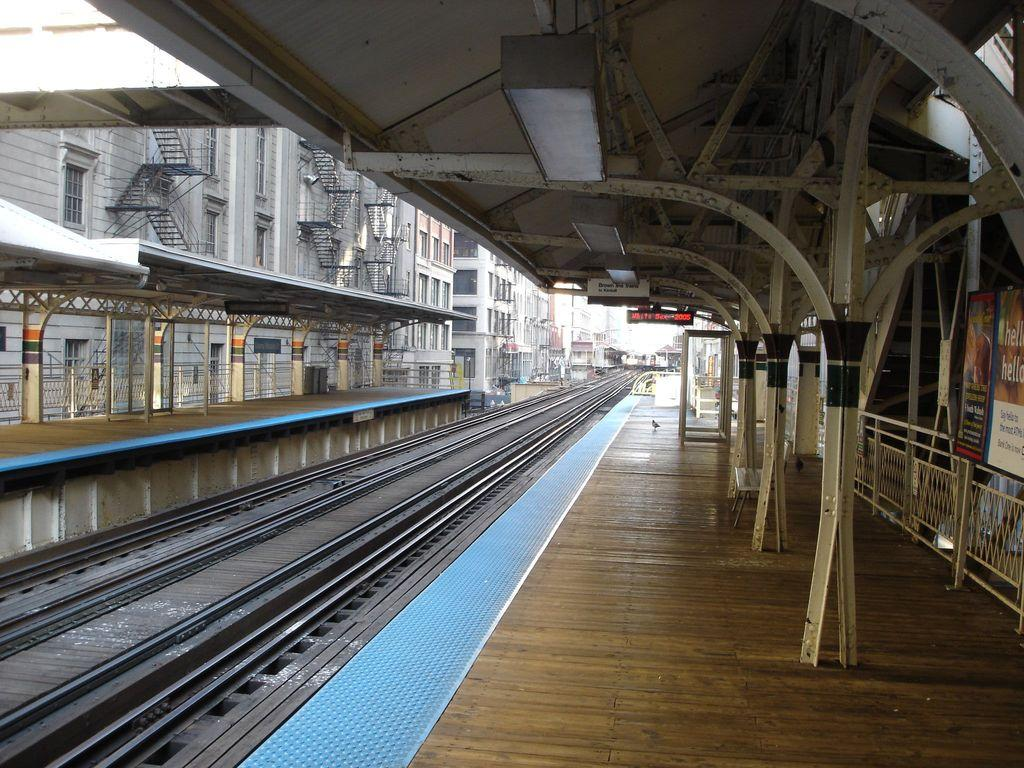What is the main structure visible in the image? There is a platform in the image. What is associated with the platform in the image? There are tracks in the image. What type of signage is present in the image? There are banners in the image. What type of signage is present on the platform? There are boards in the image. What can be seen in the background of the image? There are buildings in the background of the image. What is the color of the sky in the image? The sky is white in color. What level of the building is the middle floor in the image? There is no building or middle floor present in the image; it features a platform with tracks, banners, and boards. 